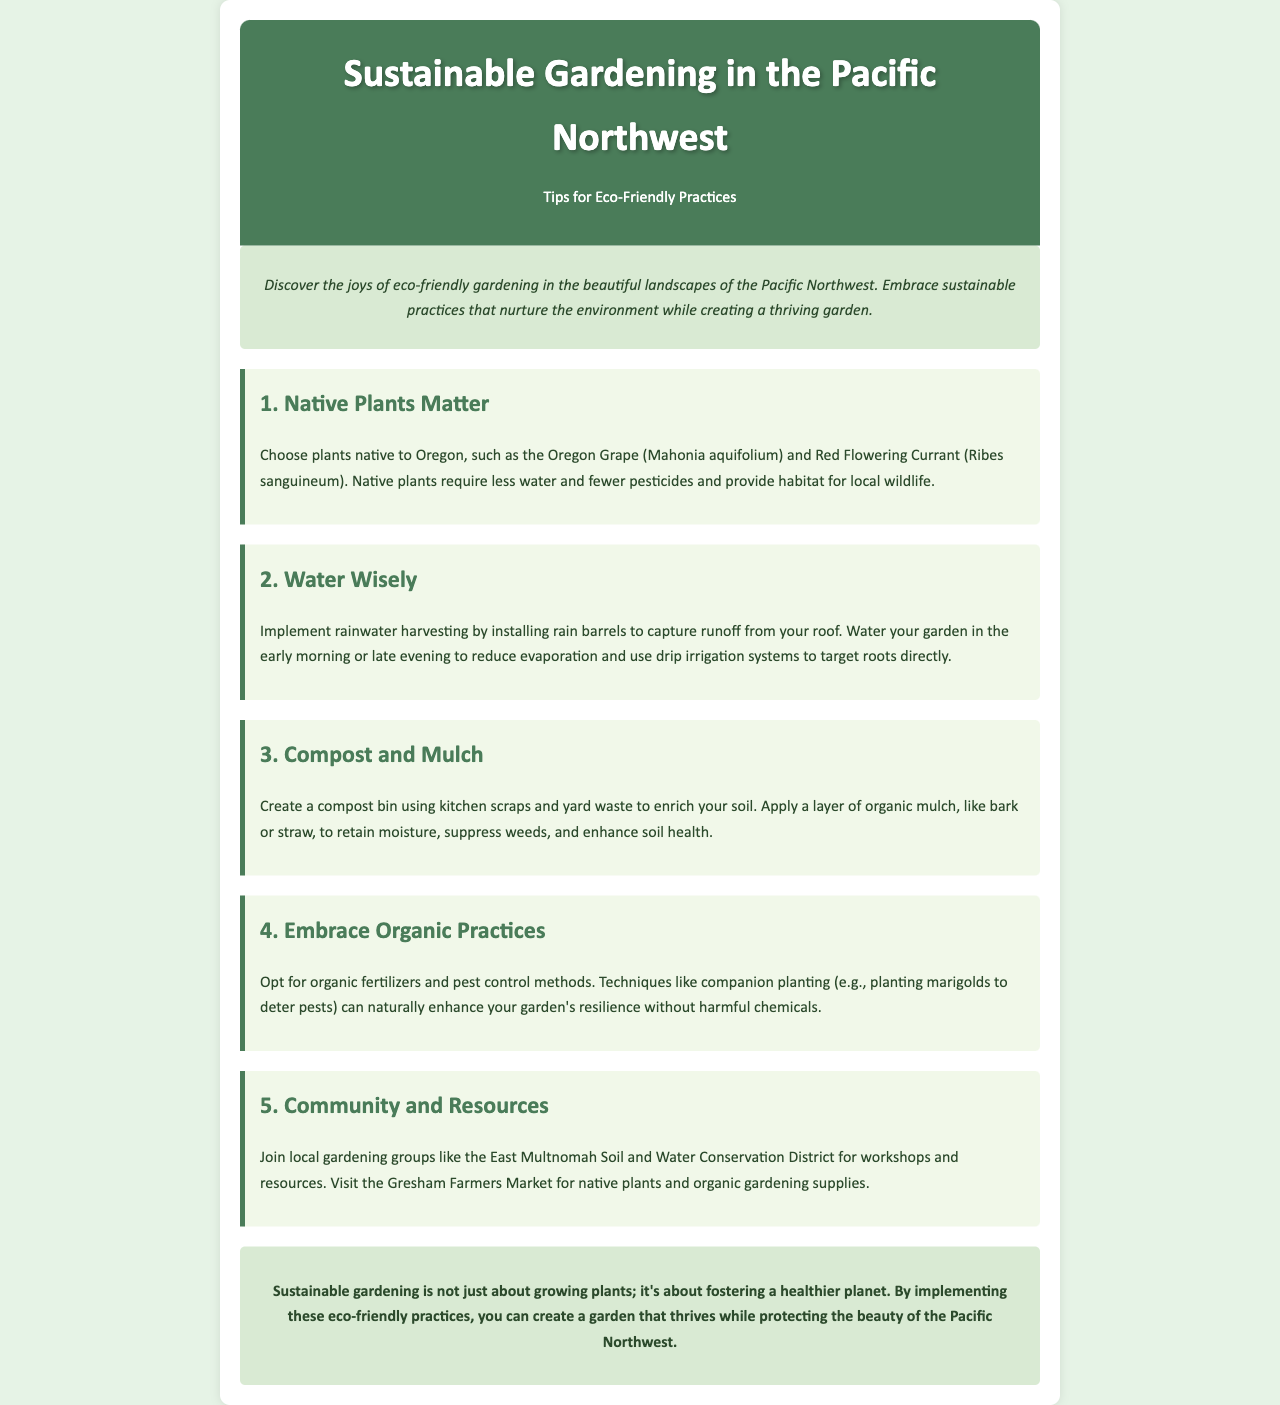What are two examples of native plants mentioned? The document lists Oregon Grape and Red Flowering Currant as examples of native plants.
Answer: Oregon Grape, Red Flowering Currant What is a recommended time to water gardens? The document suggests watering gardens in the early morning or late evening to minimize evaporation.
Answer: Early morning or late evening What is one method mentioned for enriching soil? The document recommends creating a compost bin using kitchen scraps and yard waste.
Answer: Compost bin What organic technique is mentioned to deter pests? The document refers to companion planting, specifically planting marigolds to deter pests.
Answer: Companion planting, marigolds Which community resource is suggested for local gardening groups? The document mentions the East Multnomah Soil and Water Conservation District as a resource for workshops and information.
Answer: East Multnomah Soil and Water Conservation District 